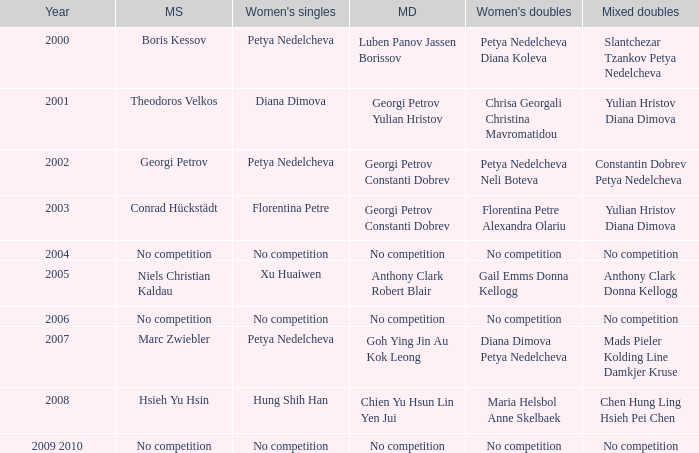What is the year when Conrad Hückstädt won Men's Single? 2003.0. 